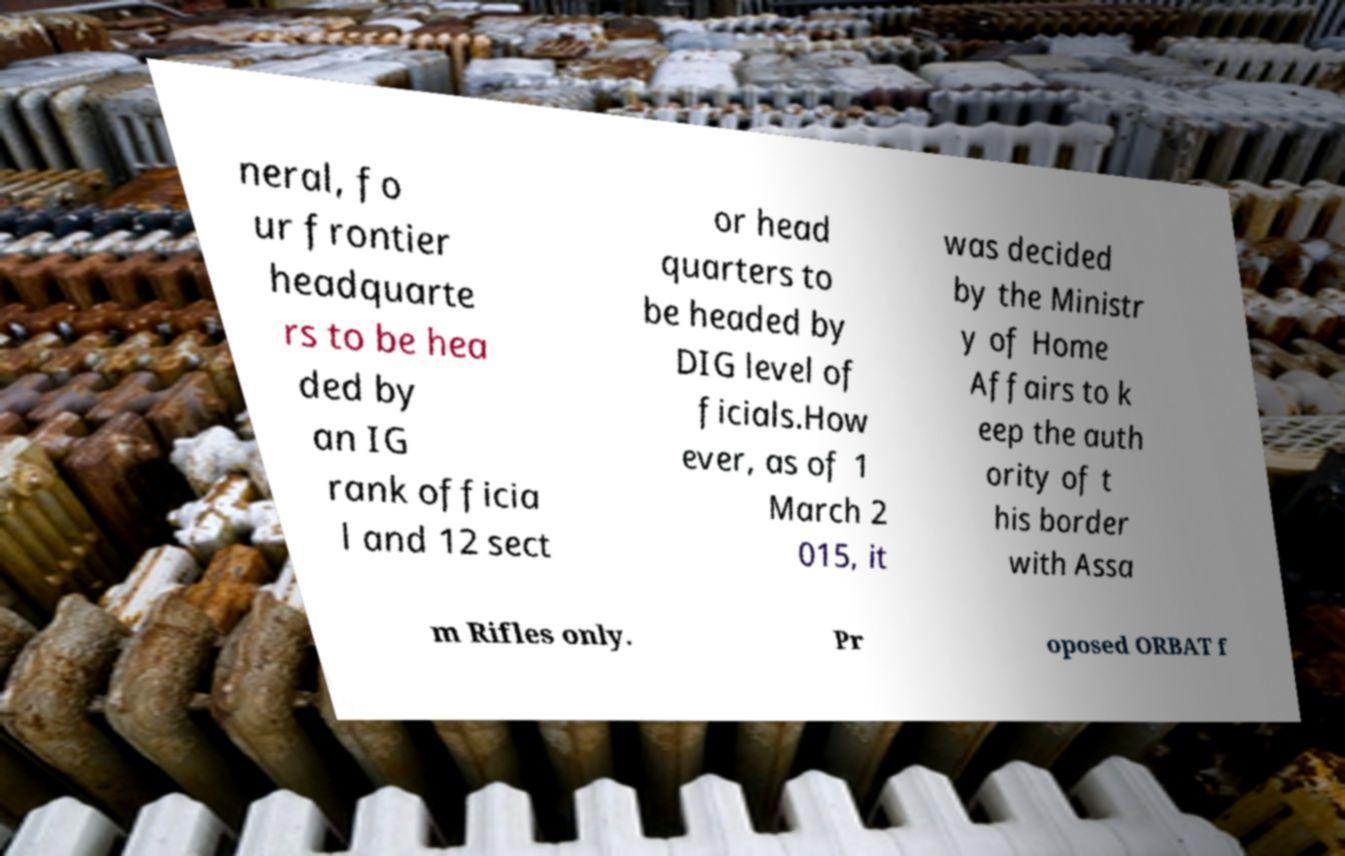Could you extract and type out the text from this image? neral, fo ur frontier headquarte rs to be hea ded by an IG rank officia l and 12 sect or head quarters to be headed by DIG level of ficials.How ever, as of 1 March 2 015, it was decided by the Ministr y of Home Affairs to k eep the auth ority of t his border with Assa m Rifles only. Pr oposed ORBAT f 